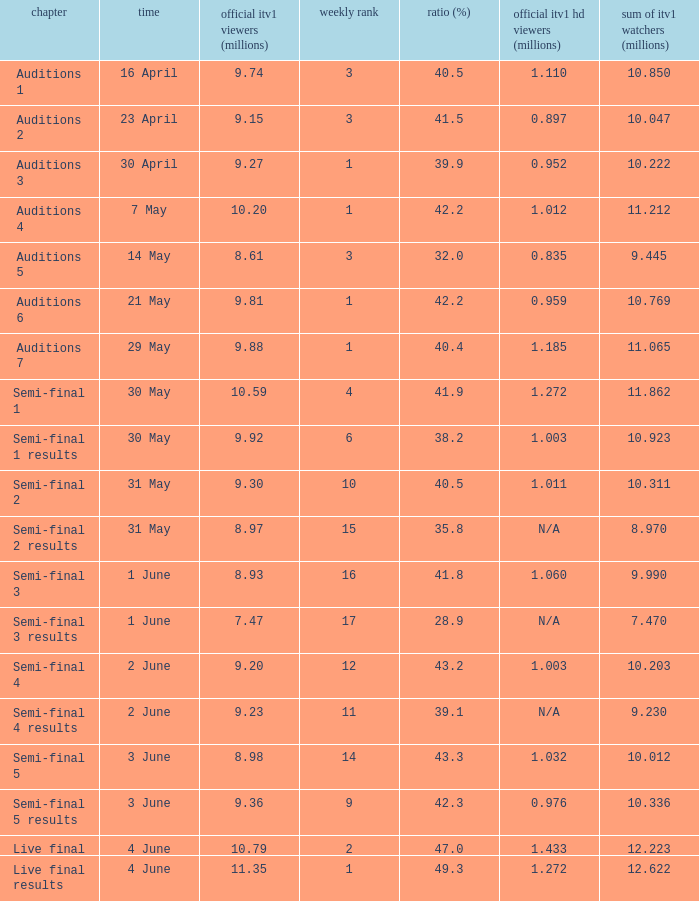Which episode had an official ITV1 HD rating of 1.185 million?  Auditions 7. 